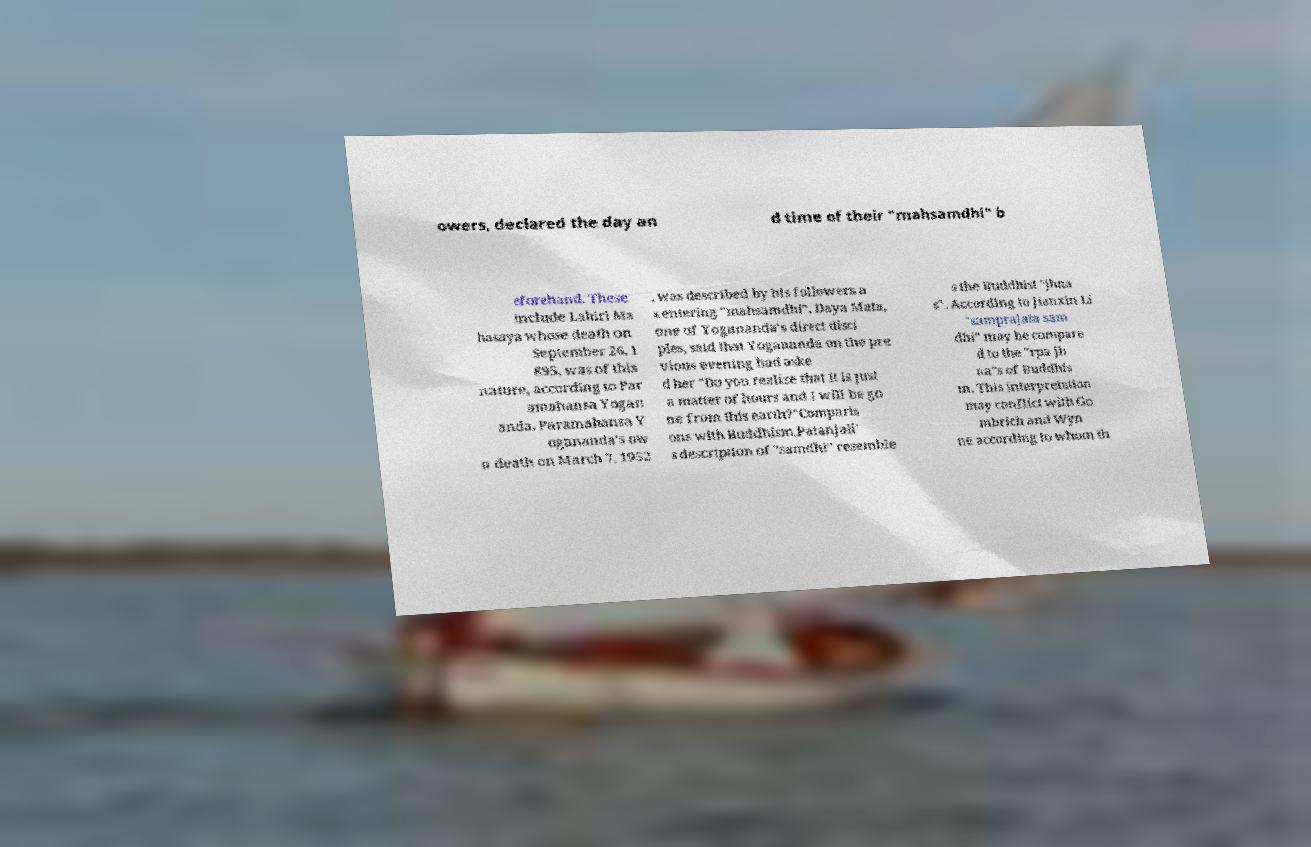For documentation purposes, I need the text within this image transcribed. Could you provide that? owers, declared the day an d time of their "mahsamdhi" b eforehand. These include Lahiri Ma hasaya whose death on September 26, 1 895, was of this nature, according to Par amahansa Yogan anda. Paramahansa Y ogananda's ow n death on March 7, 1952 , was described by his followers a s entering "mahsamdhi". Daya Mata, one of Yogananda's direct disci ples, said that Yogananda on the pre vious evening had aske d her "Do you realize that it is just a matter of hours and I will be go ne from this earth?"Comparis ons with Buddhism.Patanjali' s description of "samdhi" resemble s the Buddhist "jhna s". According to Jianxin Li "samprajata sam dhi" may be compare d to the "rpa jh na"s of Buddhis m. This interpretation may conflict with Go mbrich and Wyn ne according to whom th 